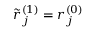Convert formula to latex. <formula><loc_0><loc_0><loc_500><loc_500>\tilde { r } _ { j } ^ { ( 1 ) } = r _ { j } ^ { ( 0 ) }</formula> 